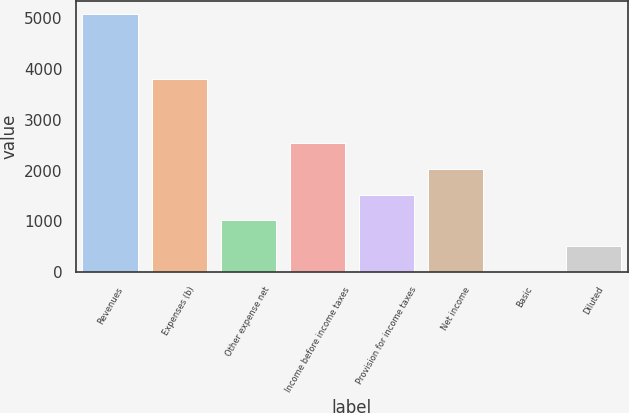Convert chart to OTSL. <chart><loc_0><loc_0><loc_500><loc_500><bar_chart><fcel>Revenues<fcel>Expenses (b)<fcel>Other expense net<fcel>Income before income taxes<fcel>Provision for income taxes<fcel>Net income<fcel>Basic<fcel>Diluted<nl><fcel>5083.6<fcel>3800.9<fcel>1017.69<fcel>2542.41<fcel>1525.93<fcel>2034.17<fcel>1.21<fcel>509.45<nl></chart> 